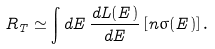Convert formula to latex. <formula><loc_0><loc_0><loc_500><loc_500>R _ { T } \simeq \int d E \, \frac { d L ( E ) } { d E } \, [ n \sigma ( E ) ] \, .</formula> 